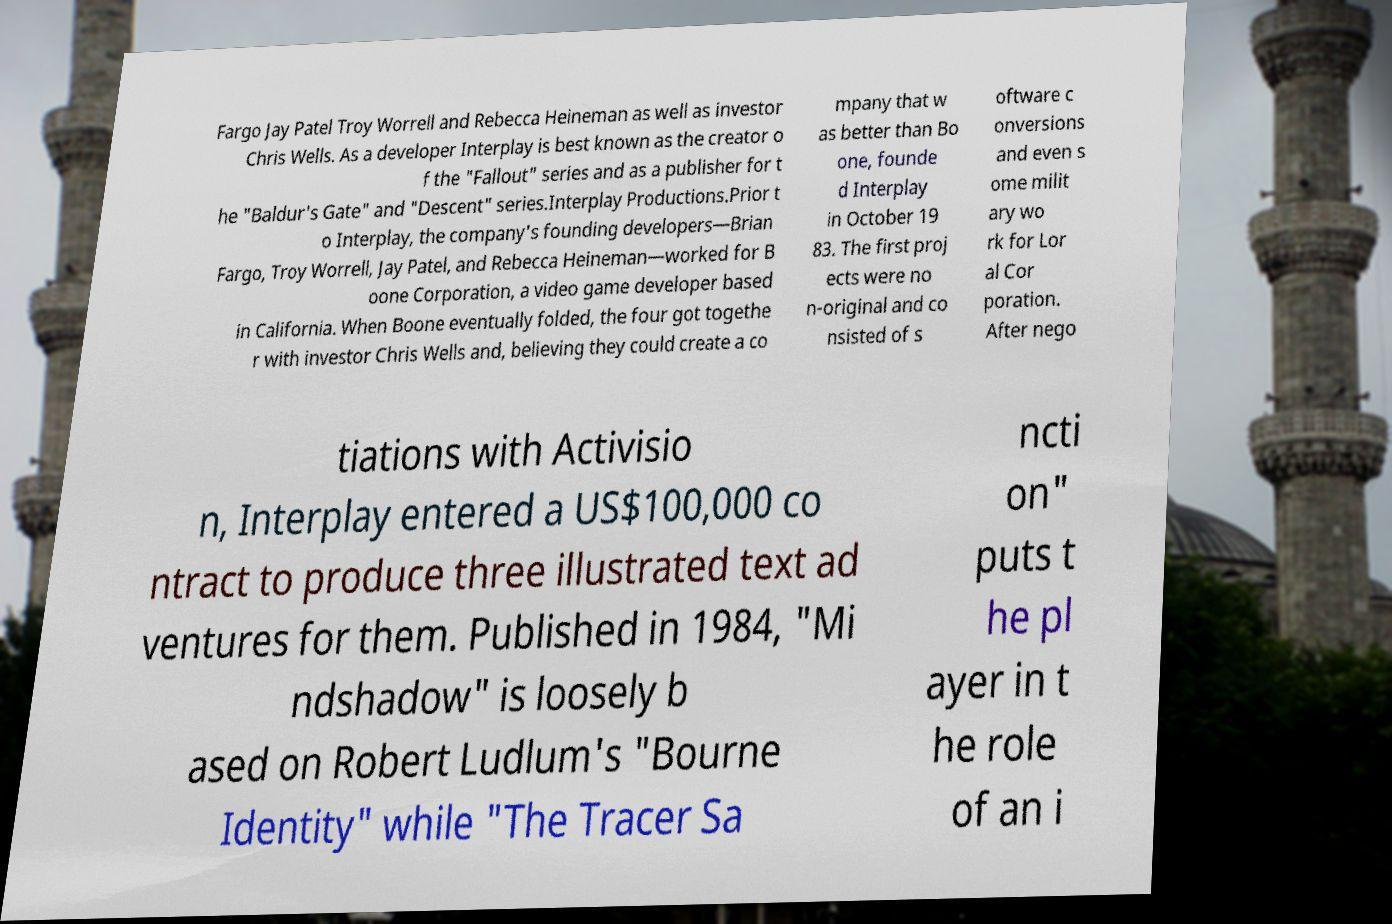Could you assist in decoding the text presented in this image and type it out clearly? Fargo Jay Patel Troy Worrell and Rebecca Heineman as well as investor Chris Wells. As a developer Interplay is best known as the creator o f the "Fallout" series and as a publisher for t he "Baldur's Gate" and "Descent" series.Interplay Productions.Prior t o Interplay, the company's founding developers—Brian Fargo, Troy Worrell, Jay Patel, and Rebecca Heineman—worked for B oone Corporation, a video game developer based in California. When Boone eventually folded, the four got togethe r with investor Chris Wells and, believing they could create a co mpany that w as better than Bo one, founde d Interplay in October 19 83. The first proj ects were no n-original and co nsisted of s oftware c onversions and even s ome milit ary wo rk for Lor al Cor poration. After nego tiations with Activisio n, Interplay entered a US$100,000 co ntract to produce three illustrated text ad ventures for them. Published in 1984, "Mi ndshadow" is loosely b ased on Robert Ludlum's "Bourne Identity" while "The Tracer Sa ncti on" puts t he pl ayer in t he role of an i 